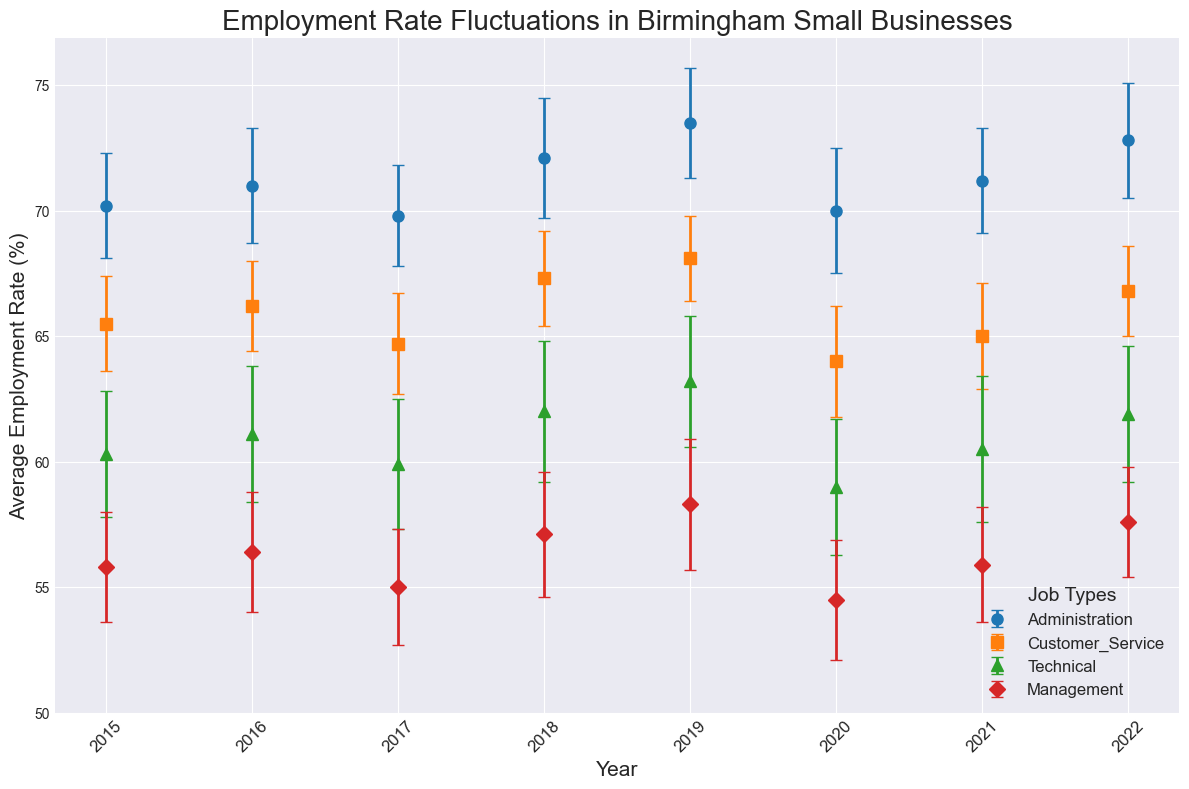What's the average employment rate for Administration jobs in 2016 and 2018? Look at the Average Employment Rate for Administration jobs in 2016 (71.0) and 2018 (72.1). The average is (71.0 + 72.1) / 2 = 71.55
Answer: 71.55 In which year was the employment rate for Technical jobs at its highest? Check the Average Employment Rates for Technical jobs across all years. The highest rate is 63.2 in 2019.
Answer: 2019 How much did the employment rate for Management jobs change from 2015 to 2016? Subtract the Average Employment Rate for Management jobs in 2015 (55.8) from the rate in 2016 (56.4). The change is 56.4 - 55.8 = 0.6
Answer: 0.6 Which job type has the smallest standard deviation in 2020? Compare the Standard Deviation of each job type in 2020. Customer Service has the smallest standard deviation of 2.2 compared to other job types.
Answer: Customer Service What was the employment rate trend for Customer Service jobs from 2017 to 2019? Look at the Average Employment Rates for Customer Service jobs from 2017 (64.7), 2018 (67.3), and 2019 (68.1). The trend is increasing.
Answer: Increasing Which job type had the most consistent employment rate over the years? Determine consistency by looking at the standard deviations for each job type across all years. Administration has the smallest variations in standard deviations (all values close to ~2.2).
Answer: Administration How did the employment rate for Technical jobs compare to Customer Service jobs in 2022? Compare the Average Employment Rates for Technical (61.9) and Customer Service (66.8) jobs in 2022. The employment rate for Customer Service was higher.
Answer: Customer Service had a higher rate What was the average standard deviation for Management jobs over all the years? Sum the standard deviations for Management over all years (2.2 + 2.4 + 2.3 + 2.5 + 2.6 + 2.4 + 2.3 + 2.2) = 19.9. The average is 19.9 / 8 = 2.49
Answer: 2.49 Did any job type experience a decrease in employment rate in 2020 compared to 2019? Compare the Average Employment Rates in 2020 and 2019 for each job type. Administration (73.5 to 70.0), Customer Service (68.1 to 64.0), Technical (63.2 to 59.0), and Management (58.3 to 54.5) all experienced decreases.
Answer: Yes, all job types 